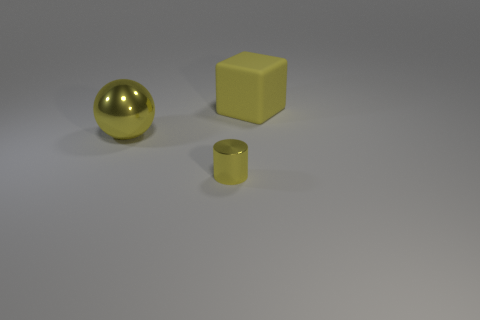What number of cylinders are the same color as the large shiny object?
Give a very brief answer. 1. There is a block that is the same color as the large metallic sphere; what is its material?
Your answer should be compact. Rubber. What is the material of the yellow cylinder?
Make the answer very short. Metal. Are the big object left of the yellow cylinder and the tiny object made of the same material?
Provide a succinct answer. Yes. What shape is the big object left of the block?
Ensure brevity in your answer.  Sphere. There is a yellow thing that is the same size as the yellow sphere; what is it made of?
Your answer should be very brief. Rubber. How many objects are either metal things that are on the left side of the tiny shiny cylinder or objects left of the big matte block?
Offer a very short reply. 2. What size is the other yellow object that is made of the same material as the small yellow object?
Offer a terse response. Large. How many rubber things are red balls or small yellow cylinders?
Offer a terse response. 0. What size is the matte thing?
Offer a terse response. Large. 